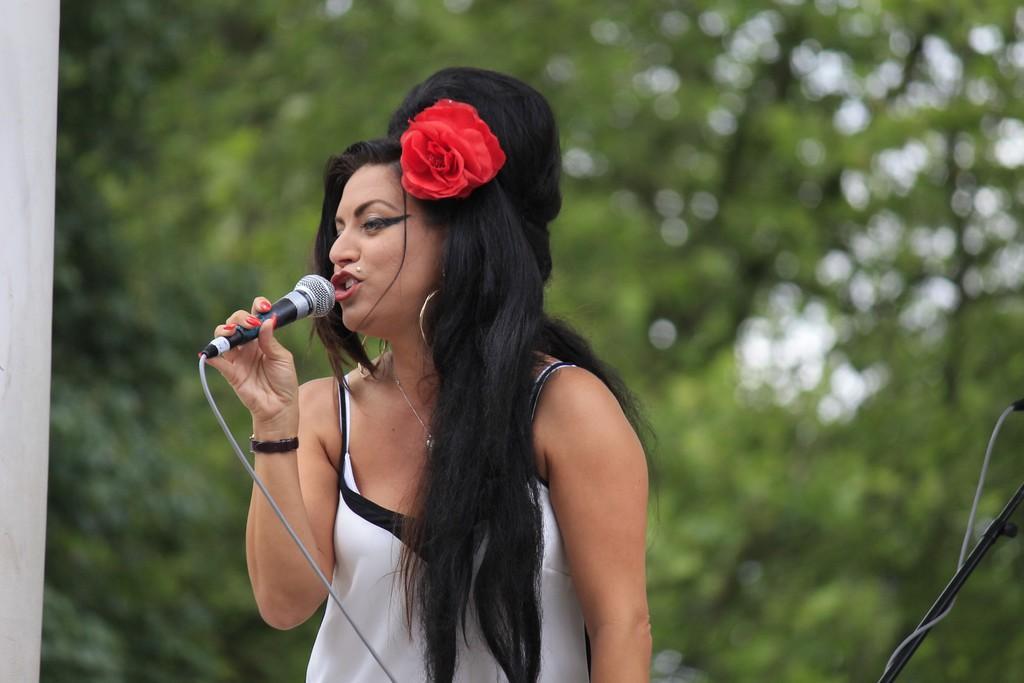Describe this image in one or two sentences. In the image in the center we can see the woman she is singing,and she is holding microphone. 